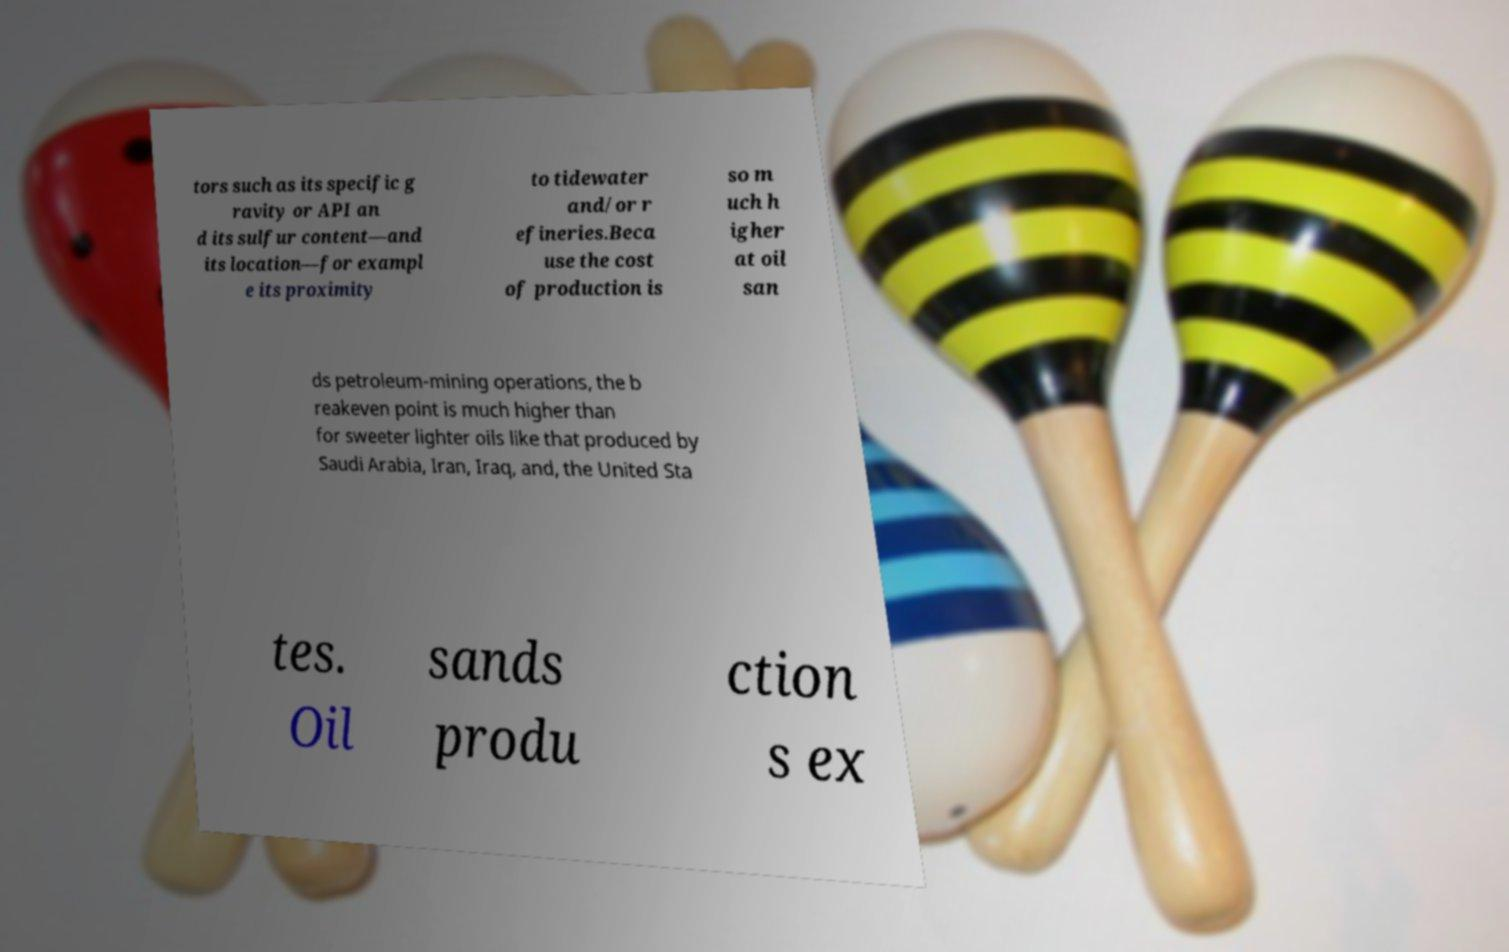Can you accurately transcribe the text from the provided image for me? tors such as its specific g ravity or API an d its sulfur content—and its location—for exampl e its proximity to tidewater and/or r efineries.Beca use the cost of production is so m uch h igher at oil san ds petroleum-mining operations, the b reakeven point is much higher than for sweeter lighter oils like that produced by Saudi Arabia, Iran, Iraq, and, the United Sta tes. Oil sands produ ction s ex 